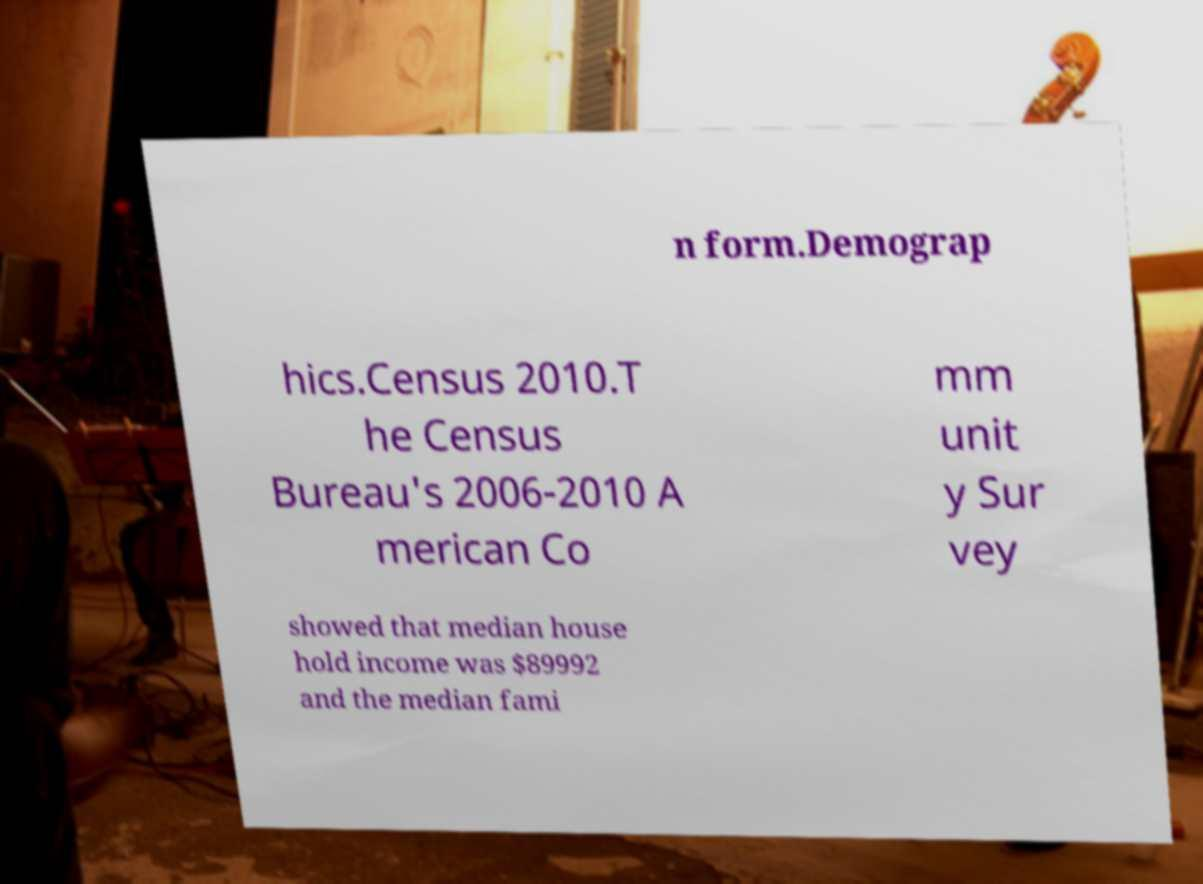For documentation purposes, I need the text within this image transcribed. Could you provide that? n form.Demograp hics.Census 2010.T he Census Bureau's 2006-2010 A merican Co mm unit y Sur vey showed that median house hold income was $89992 and the median fami 